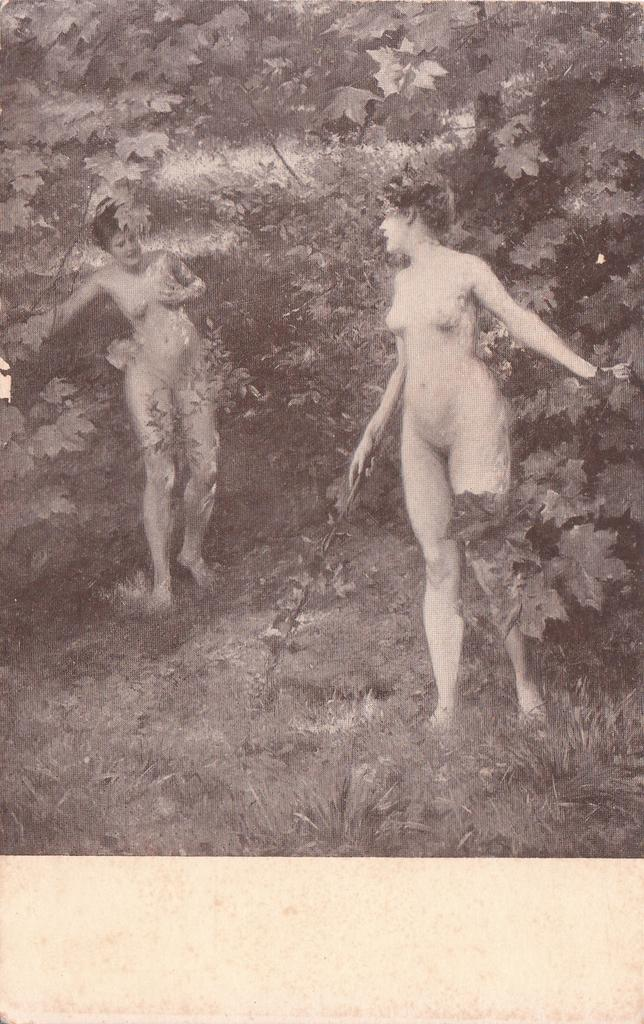What types of living organisms can be seen in the image? Plants can be seen in the image. How many people are present in the image? There are two persons in the image. What type of cabbage can be seen growing in the image? There is no cabbage present in the image; it only features plants. Can you tell me how fast the persons are running in the image? There is no indication that the persons are running in the image; they are simply standing or interacting with the plants. 